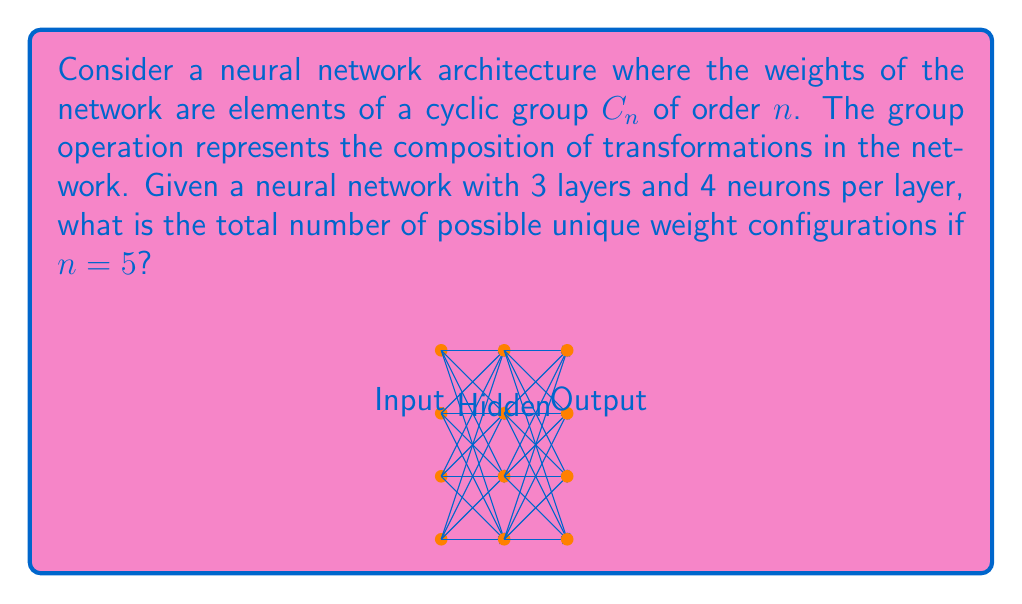What is the answer to this math problem? Let's approach this step-by-step:

1) First, we need to count the number of connections between neurons:
   - From input to hidden layer: 4 * 4 = 16 connections
   - From hidden to output layer: 4 * 4 = 16 connections
   - Total connections: 16 + 16 = 32 connections

2) Each connection can have a weight from the cyclic group $C_5$, which has 5 elements.

3) For each connection, we have 5 choices of weights.

4) Since the choices for each connection are independent, we use the multiplication principle of counting.

5) The total number of possible weight configurations is:

   $$ 5^{32} $$

6) This is because we have 5 choices for each of the 32 connections.

7) To calculate this:
   $$ 5^{32} = 2.32830643654 \times 10^{22} $$

Therefore, there are approximately $2.33 \times 10^{22}$ possible unique weight configurations.
Answer: $5^{32} \approx 2.33 \times 10^{22}$ 